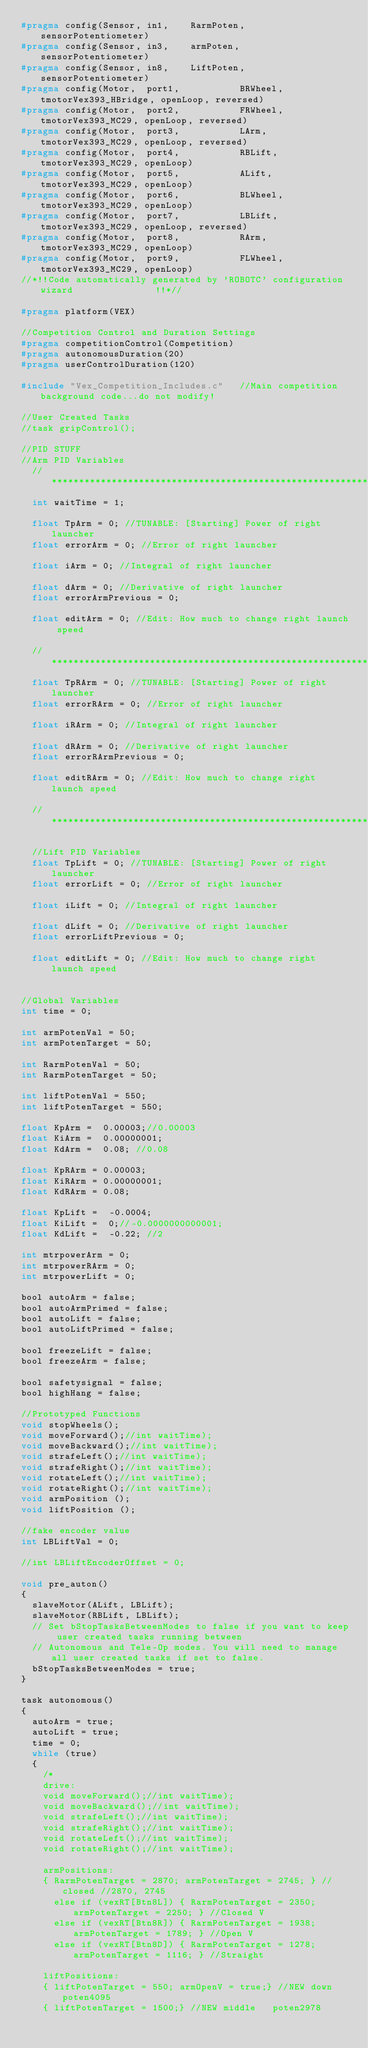<code> <loc_0><loc_0><loc_500><loc_500><_C_>#pragma config(Sensor, in1,    RarmPoten,      sensorPotentiometer)
#pragma config(Sensor, in3,    armPoten,       sensorPotentiometer)
#pragma config(Sensor, in8,    LiftPoten,      sensorPotentiometer)
#pragma config(Motor,  port1,           BRWheel,       tmotorVex393_HBridge, openLoop, reversed)
#pragma config(Motor,  port2,           FRWheel,       tmotorVex393_MC29, openLoop, reversed)
#pragma config(Motor,  port3,           LArm,          tmotorVex393_MC29, openLoop, reversed)
#pragma config(Motor,  port4,           RBLift,        tmotorVex393_MC29, openLoop)
#pragma config(Motor,  port5,           ALift,         tmotorVex393_MC29, openLoop)
#pragma config(Motor,  port6,           BLWheel,       tmotorVex393_MC29, openLoop)
#pragma config(Motor,  port7,           LBLift,        tmotorVex393_MC29, openLoop, reversed)
#pragma config(Motor,  port8,           RArm,          tmotorVex393_MC29, openLoop)
#pragma config(Motor,  port9,           FLWheel,       tmotorVex393_MC29, openLoop)
//*!!Code automatically generated by 'ROBOTC' configuration wizard               !!*//

#pragma platform(VEX)

//Competition Control and Duration Settings
#pragma competitionControl(Competition)
#pragma autonomousDuration(20)
#pragma userControlDuration(120)

#include "Vex_Competition_Includes.c"   //Main competition background code...do not modify!

//User Created Tasks
//task gripControl();

//PID STUFF
//Arm PID Variables
	//***********************************************************************
	int waitTime = 1;

	float TpArm = 0; //TUNABLE: [Starting] Power of right launcher
	float errorArm = 0; //Error of right launcher

	float iArm = 0; //Integral of right launcher

	float dArm = 0; //Derivative of right launcher
	float errorArmPrevious = 0;

	float editArm = 0; //Edit: How much to change right launch speed

	//*********************************************************************
	float TpRArm = 0; //TUNABLE: [Starting] Power of right launcher
	float errorRArm = 0; //Error of right launcher

	float iRArm = 0; //Integral of right launcher

	float dRArm = 0; //Derivative of right launcher
	float errorRArmPrevious = 0;

	float editRArm = 0; //Edit: How much to change right launch speed

	//***************************************************************************

	//Lift PID Variables
	float TpLift = 0; //TUNABLE: [Starting] Power of right launcher
	float errorLift = 0; //Error of right launcher

	float iLift = 0; //Integral of right launcher

	float dLift = 0; //Derivative of right launcher
	float errorLiftPrevious = 0;

	float editLift = 0; //Edit: How much to change right launch speed


//Global Variables
int time = 0;

int armPotenVal = 50;
int armPotenTarget = 50;

int RarmPotenVal = 50;
int RarmPotenTarget = 50;

int liftPotenVal = 550;
int liftPotenTarget = 550;

float KpArm =  0.00003;//0.00003
float KiArm =  0.00000001;
float KdArm =  0.08; //0.08

float KpRArm = 0.00003;
float KiRArm = 0.00000001;
float KdRArm = 0.08;

float KpLift =  -0.0004;
float KiLift =  0;//-0.0000000000001;
float KdLift =  -0.22; //2

int mtrpowerArm = 0;
int mtrpowerRArm = 0;
int mtrpowerLift = 0;

bool autoArm = false;
bool autoArmPrimed = false;
bool autoLift = false;
bool autoLiftPrimed = false;

bool freezeLift = false;
bool freezeArm = false;

bool safetysignal = false;
bool highHang = false;

//Prototyped Functions
void stopWheels();
void moveForward();//int waitTime);
void moveBackward();//int waitTime);
void strafeLeft();//int waitTime);
void strafeRight();//int waitTime);
void rotateLeft();//int waitTime);
void rotateRight();//int waitTime);
void armPosition ();
void liftPosition ();

//fake encoder value
int LBLiftVal = 0;

//int LBLiftEncoderOffset = 0;

void pre_auton()
{
	slaveMotor(ALift, LBLift);
	slaveMotor(RBLift, LBLift);
	// Set bStopTasksBetweenModes to false if you want to keep user created tasks running between
	// Autonomous and Tele-Op modes. You will need to manage all user created tasks if set to false.
	bStopTasksBetweenModes = true;
}

task autonomous()
{
	autoArm = true;
	autoLift = true;
	time = 0;
	while (true)
	{
		/*
		drive:
		void moveForward();//int waitTime);
		void moveBackward();//int waitTime);
		void strafeLeft();//int waitTime);
		void strafeRight();//int waitTime);
		void rotateLeft();//int waitTime);
		void rotateRight();//int waitTime);

		armPositions:
		{ RarmPotenTarget = 2870; armPotenTarget = 2745; } //closed //2870, 2745
			else if (vexRT[Btn8L]) { RarmPotenTarget = 2350; armPotenTarget = 2250; } //Closed V
			else if (vexRT[Btn8R]) { RarmPotenTarget = 1938; armPotenTarget = 1789; } //Open V
			else if (vexRT[Btn8D]) { RarmPotenTarget = 1278; armPotenTarget = 1116; } //Straight

		liftPositions:
		{ liftPotenTarget = 550; armOpenV = true;} //NEW down	poten4095
		{ liftPotenTarget = 1500;} //NEW middle 	poten2978</code> 